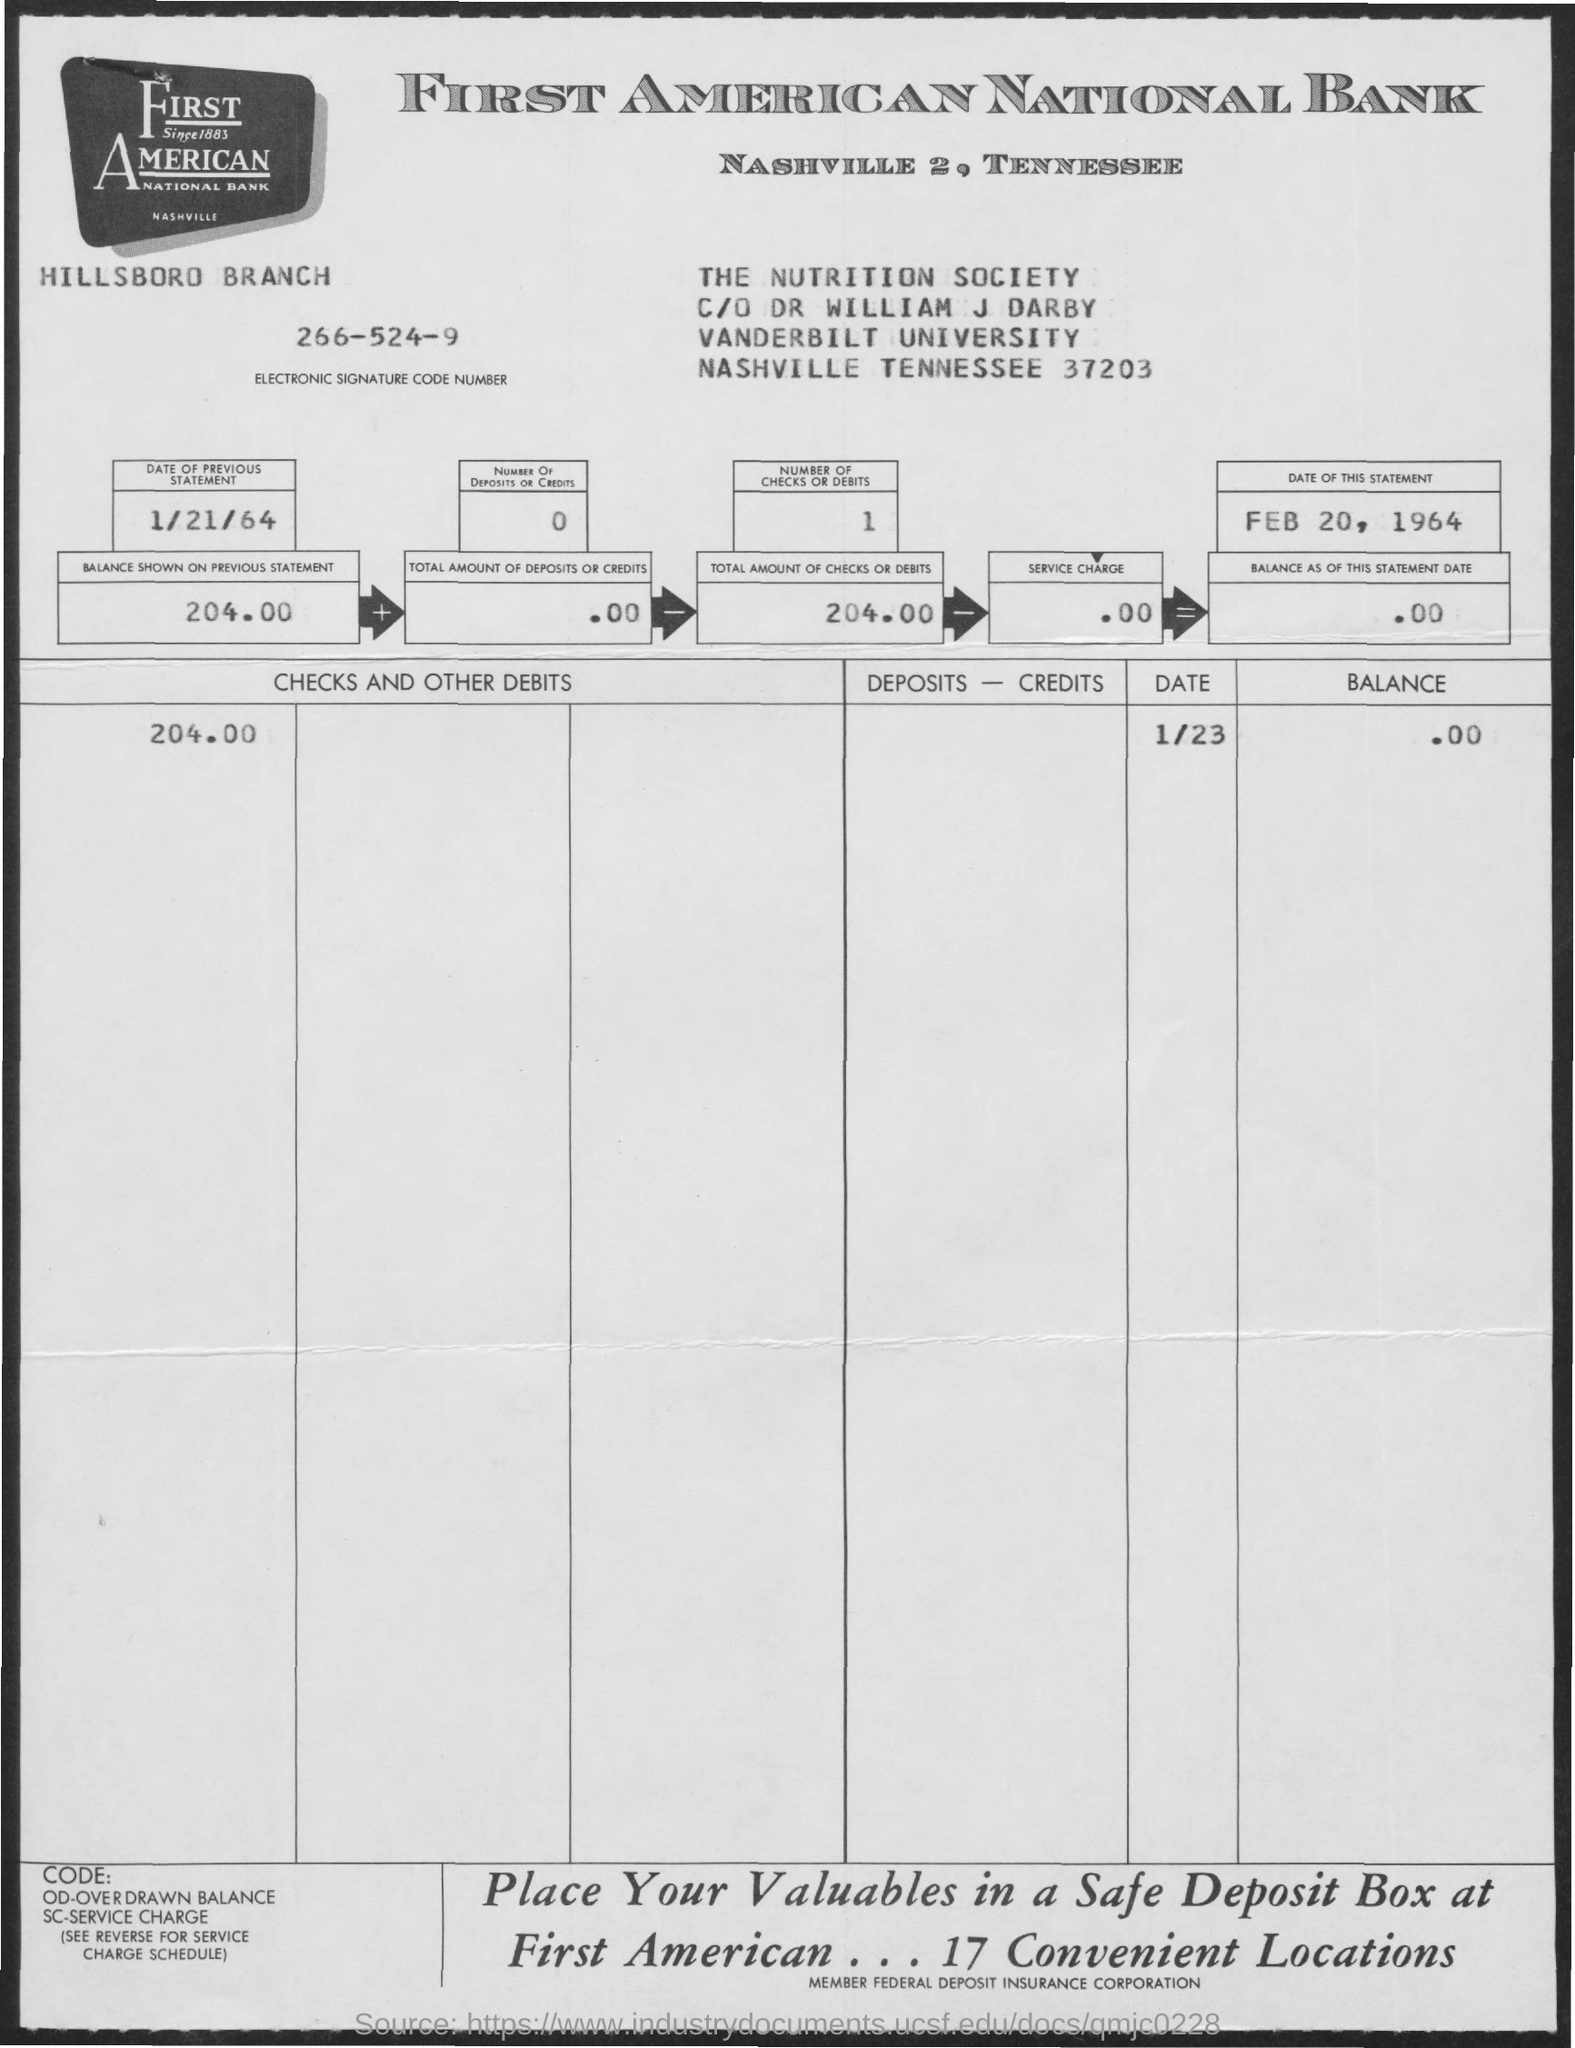What does the code at the bottom of the statement signify? The codes at the bottom of the statement likely refer to various service charges or fees that could be applied to the account. 'OD' stands for Overdrawn Balance, 'SC' is Service Charge, and there's mention of a Charge Schedule. This indicates a system to inform the account holder of potential additional costs associated with the management of their account. 